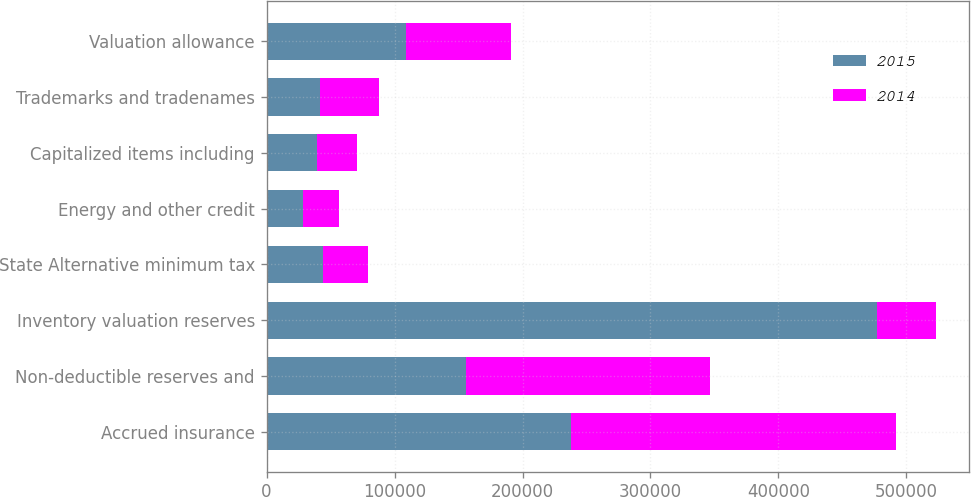<chart> <loc_0><loc_0><loc_500><loc_500><stacked_bar_chart><ecel><fcel>Accrued insurance<fcel>Non-deductible reserves and<fcel>Inventory valuation reserves<fcel>State Alternative minimum tax<fcel>Energy and other credit<fcel>Capitalized items including<fcel>Trademarks and tradenames<fcel>Valuation allowance<nl><fcel>2015<fcel>237836<fcel>155488<fcel>476673<fcel>44161<fcel>28669<fcel>39220<fcel>41664<fcel>109052<nl><fcel>2014<fcel>254031<fcel>191097<fcel>46362<fcel>34812<fcel>27858<fcel>31584<fcel>46362<fcel>82253<nl></chart> 